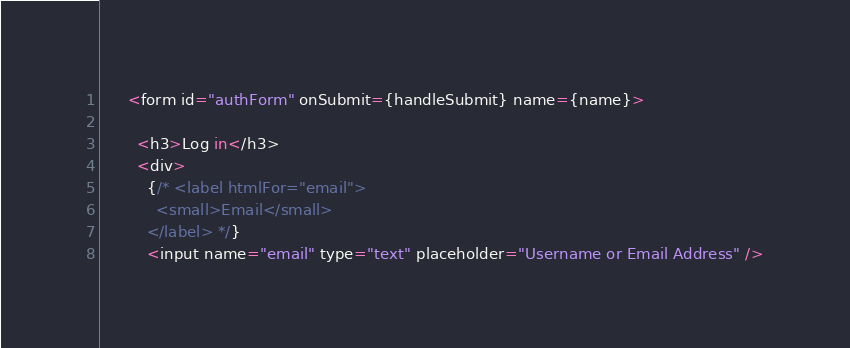<code> <loc_0><loc_0><loc_500><loc_500><_JavaScript_>      <form id="authForm" onSubmit={handleSubmit} name={name}>

        <h3>Log in</h3>
        <div>
          {/* <label htmlFor="email">
            <small>Email</small>
          </label> */}
          <input name="email" type="text" placeholder="Username or Email Address" /></code> 